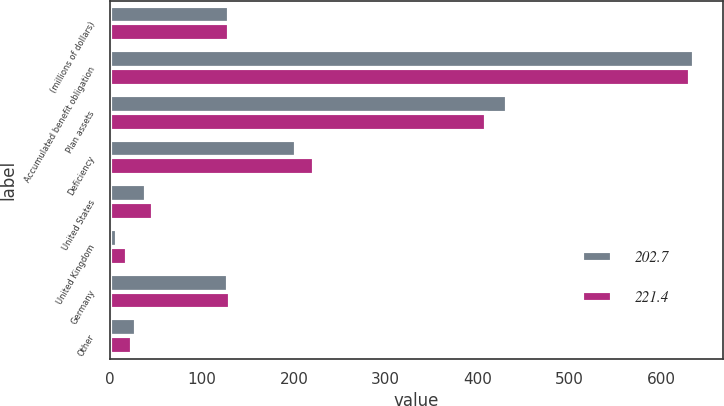<chart> <loc_0><loc_0><loc_500><loc_500><stacked_bar_chart><ecel><fcel>(millions of dollars)<fcel>Accumulated benefit obligation<fcel>Plan assets<fcel>Deficiency<fcel>United States<fcel>United Kingdom<fcel>Germany<fcel>Other<nl><fcel>202.7<fcel>129.55<fcel>634.9<fcel>432.2<fcel>202.7<fcel>39<fcel>7.5<fcel>128<fcel>28.2<nl><fcel>221.4<fcel>129.55<fcel>630.5<fcel>409.1<fcel>221.4<fcel>47.4<fcel>19.1<fcel>131.1<fcel>23.8<nl></chart> 